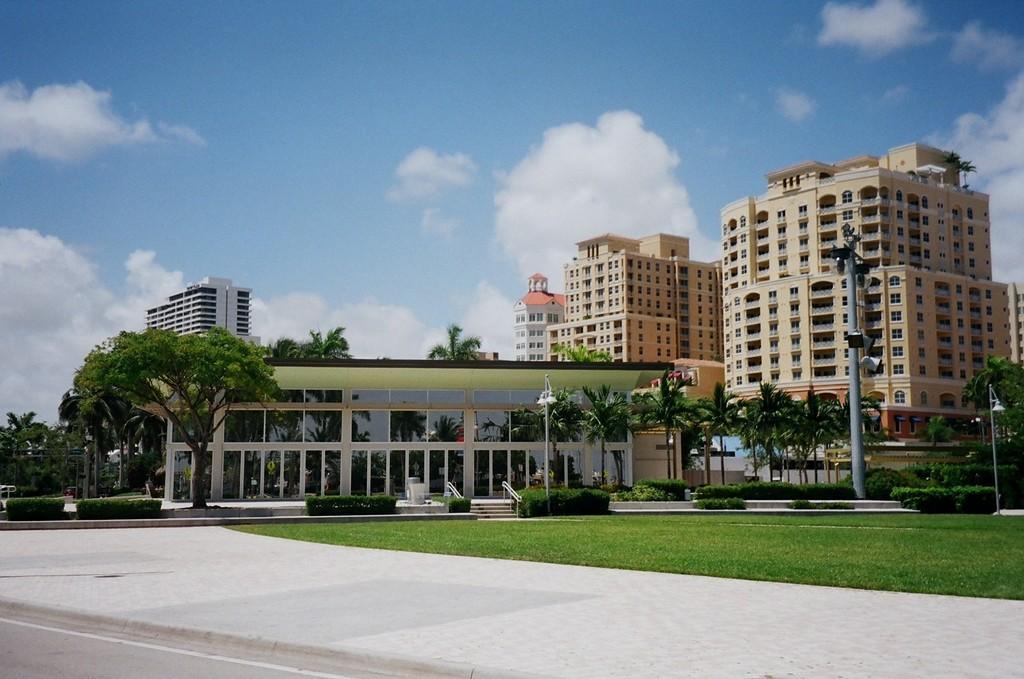Could you give a brief overview of what you see in this image? In this image we can see buildings, trees, plants, grass, road, and poles. In the background there is sky with clouds. 